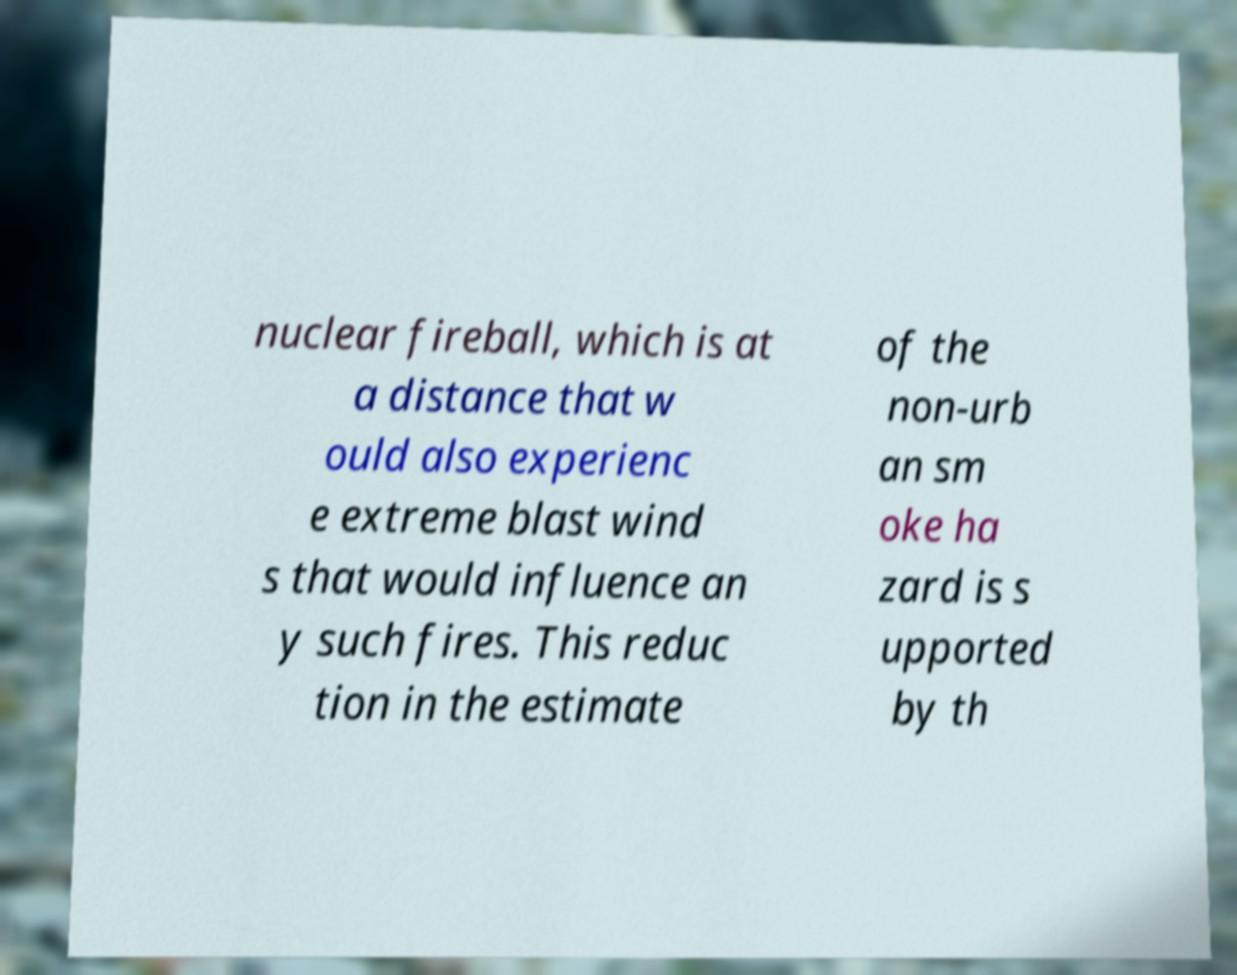There's text embedded in this image that I need extracted. Can you transcribe it verbatim? nuclear fireball, which is at a distance that w ould also experienc e extreme blast wind s that would influence an y such fires. This reduc tion in the estimate of the non-urb an sm oke ha zard is s upported by th 